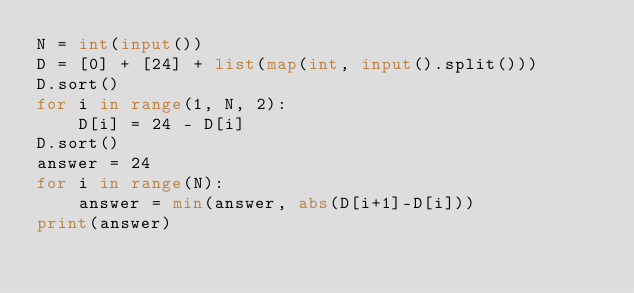<code> <loc_0><loc_0><loc_500><loc_500><_Python_>N = int(input())
D = [0] + [24] + list(map(int, input().split()))
D.sort()
for i in range(1, N, 2):
    D[i] = 24 - D[i]
D.sort()
answer = 24
for i in range(N):
    answer = min(answer, abs(D[i+1]-D[i]))
print(answer)</code> 